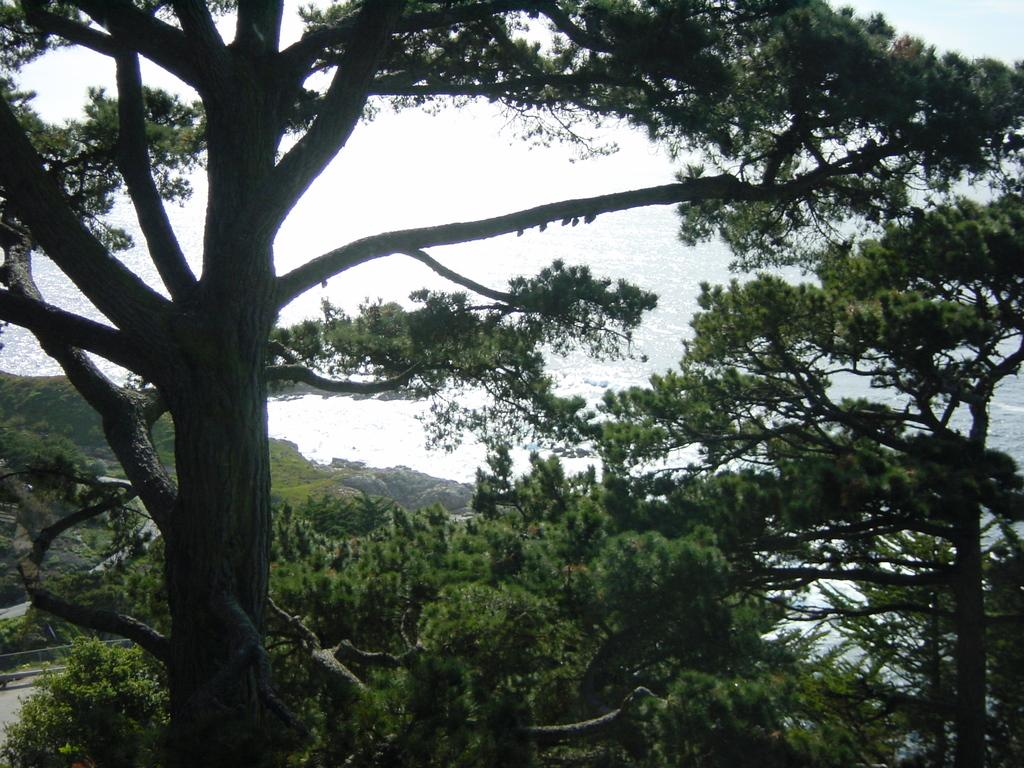What type of vegetation is present in the image? There are trees with branches and leaves in the image. Can you describe the water in the image? There appears to be water in the image. Can you see the father of the trees in the image? There is no father figure present in the image, as trees do not have parents. What type of wave is visible in the image? There is no wave visible in the image, as it does not depict a body of water with waves. 